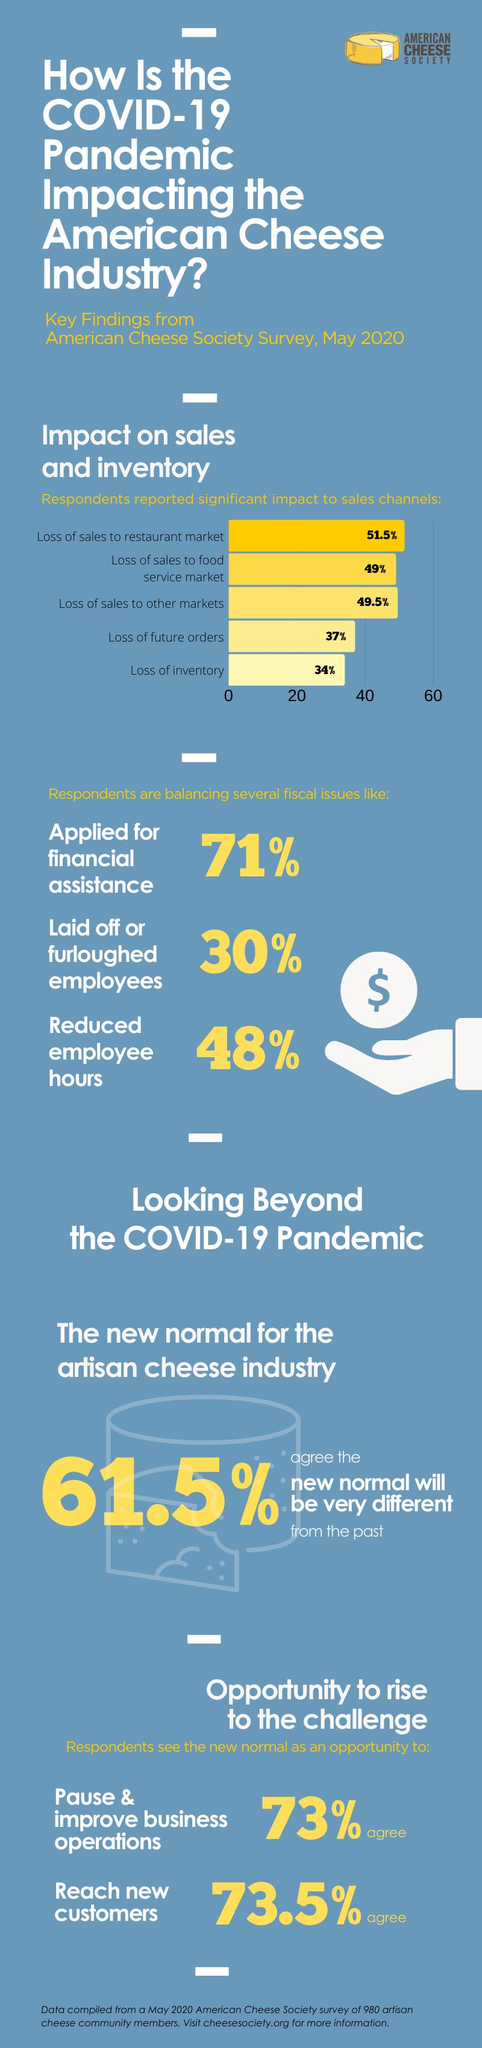Draw attention to some important aspects in this diagram. According to the American Cheese Society Survey conducted in May 2020, 49% of respondents reported a loss of sales to the food service market due to the COVID-19 pandemic. According to the American Cheese Society Survey conducted in May 2020, 34% of respondents reported a loss of inventory due to the impact of COVID-19. According to the American Cheese Society Survey in May 2020, 52% of respondents did not reduce employee hours during the COVID-19 pandemic. According to the American Cheese Society Survey conducted in May 2020, 29% of respondents did not apply for financial assistance during the COVID-19 pandemic. According to the American Cheese Society Survey conducted in May 2020, a significant percentage of respondents, 51.5%, reported a loss of sales to the restaurant market due to the impact of COVID-19. 